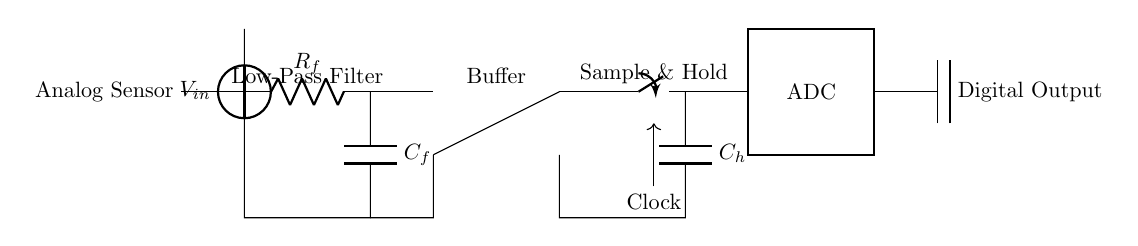What type of sensor is used in this circuit? The circuit includes an analog sensor, which is indicated at the beginning of the diagram. This element captures continuous signals.
Answer: Analog sensor What component filters high-frequency noise in the circuit? A low-pass filter, composed of a resistor and capacitor, is used to block high-frequency signals and allow low-frequency signals to pass through. It is labeled in the diagram.
Answer: Low-pass filter What is the function of the operational amplifier in this circuit? The operational amplifier (op-amp) serves as a buffer, which isolates the input from the output, prevents load effects, and provides high input impedance and low output impedance. Its location in the diagram indicates this role.
Answer: Buffer How does the sample and hold circuit function in this setup? The sample and hold circuit captures and holds a sampled voltage level for a specific duration, allowing the ADC to convert it from analog to digital. The clock signal indicates when to sample.
Answer: Holds voltage What is the primary role of the ADC in this diagram? The ADC (analog-to-digital converter) transforms the analog signals into a digital format, so they can be processed by digital systems. It is a discrete component prominently shown in the diagram.
Answer: Converts signals What is the value of the clock signal used in the sample and hold section? The clock signal frequency is implicit in the operation of the sample and hold, indicating when sampling occurs; however, the exact value is not specified in the diagram.
Answer: Not specified What happens if the low-pass filter component fails? If the low-pass filter fails, high-frequency noise could corrupt the signal reaching the buffer and ADC, resulting in inaccurate digital readings. This indicates the importance of this component in maintaining signal integrity.
Answer: Signal corruption 